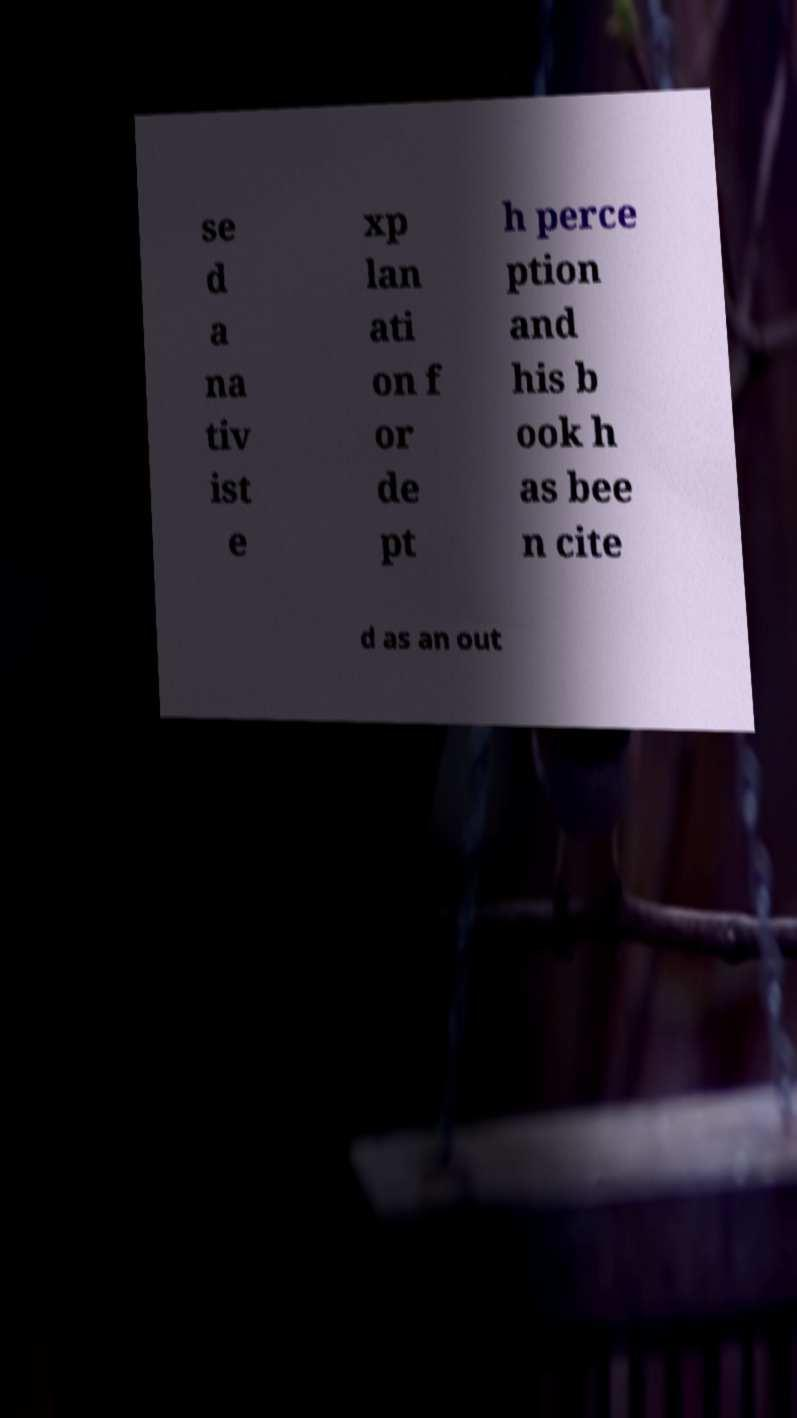Can you read and provide the text displayed in the image?This photo seems to have some interesting text. Can you extract and type it out for me? se d a na tiv ist e xp lan ati on f or de pt h perce ption and his b ook h as bee n cite d as an out 